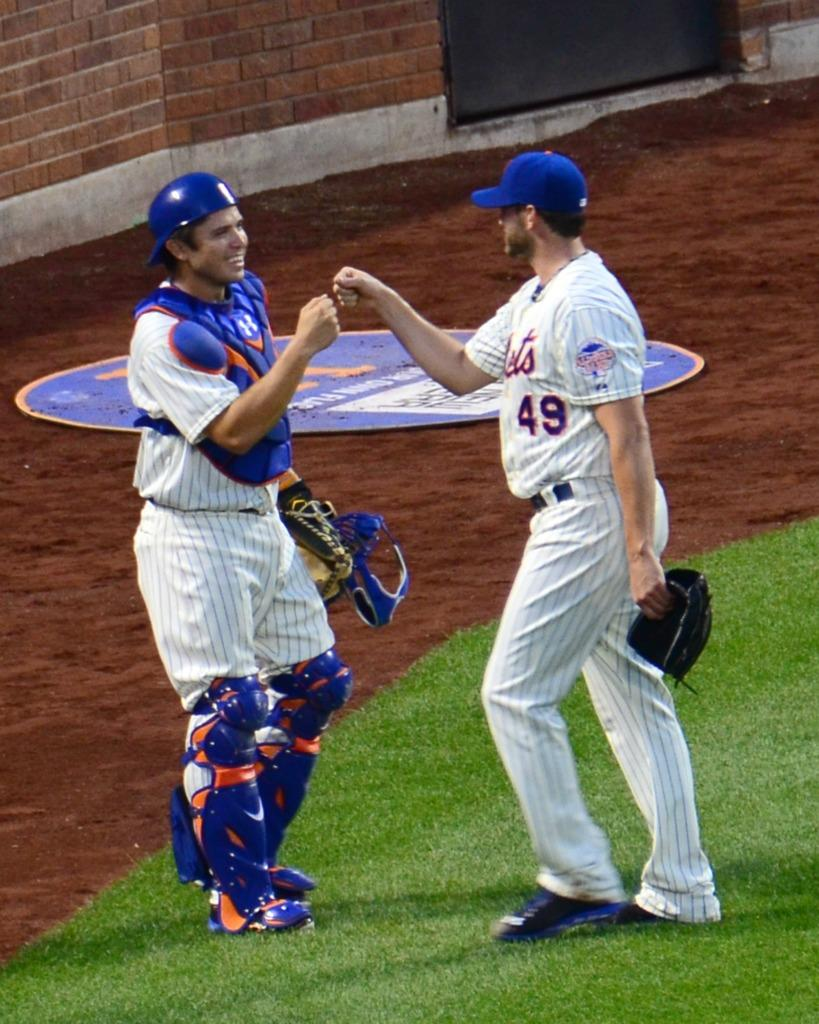Provide a one-sentence caption for the provided image. A baseball catcher exchanges a fist bump with a fellow teammate wearing number 49. 